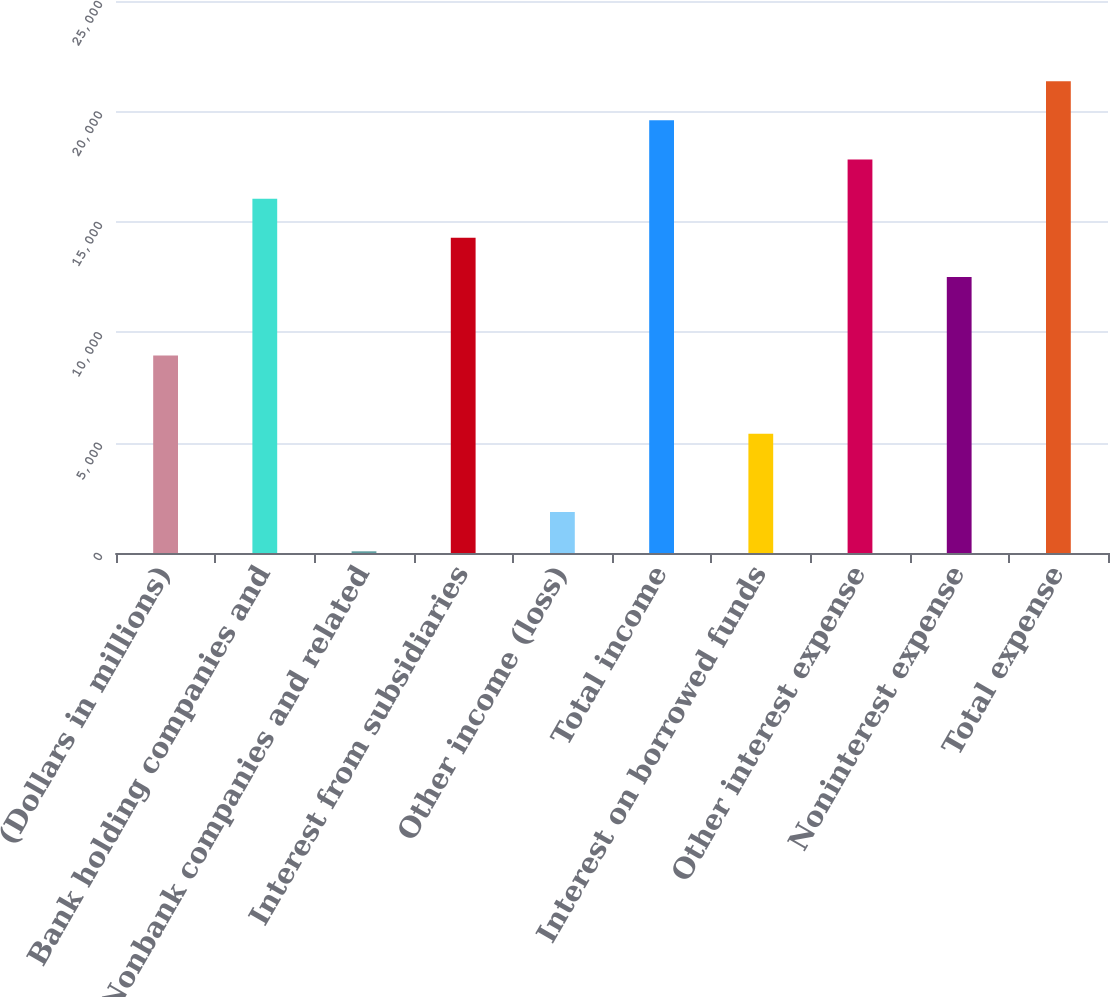Convert chart. <chart><loc_0><loc_0><loc_500><loc_500><bar_chart><fcel>(Dollars in millions)<fcel>Bank holding companies and<fcel>Nonbank companies and related<fcel>Interest from subsidiaries<fcel>Other income (loss)<fcel>Total income<fcel>Interest on borrowed funds<fcel>Other interest expense<fcel>Noninterest expense<fcel>Total expense<nl><fcel>8949.5<fcel>16047.5<fcel>77<fcel>14273<fcel>1851.5<fcel>19596.5<fcel>5400.5<fcel>17822<fcel>12498.5<fcel>21371<nl></chart> 